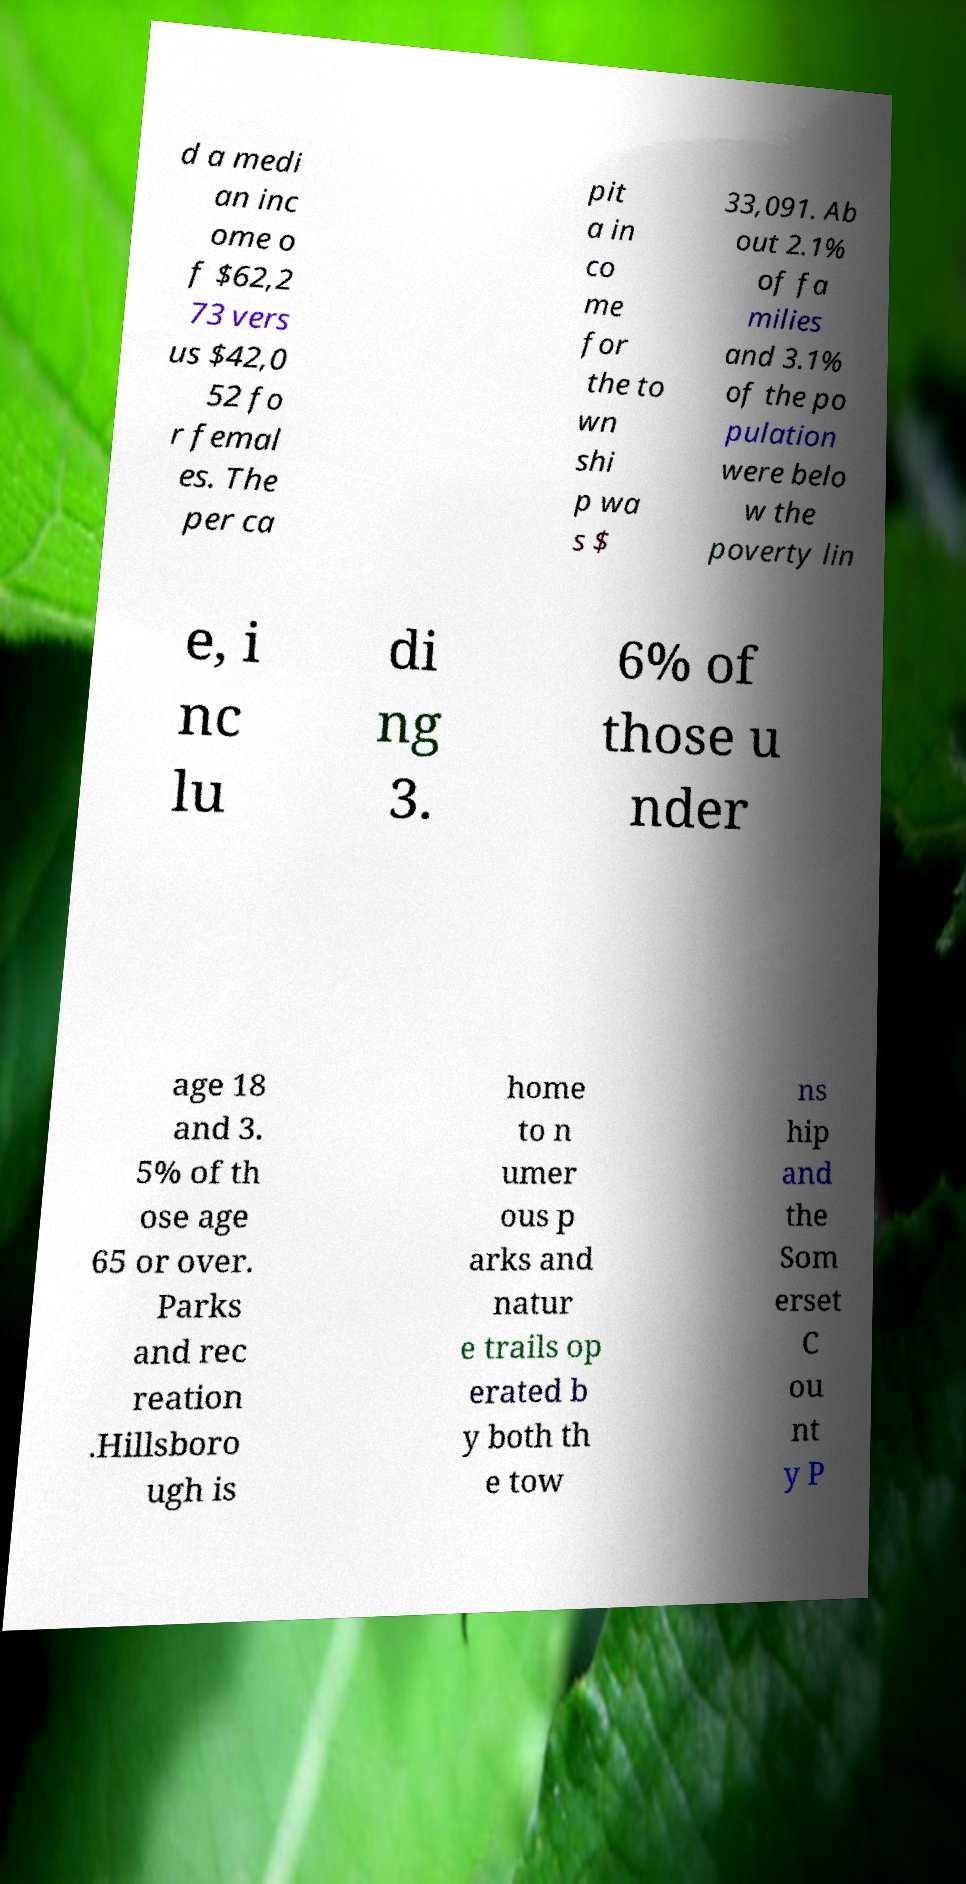Please identify and transcribe the text found in this image. d a medi an inc ome o f $62,2 73 vers us $42,0 52 fo r femal es. The per ca pit a in co me for the to wn shi p wa s $ 33,091. Ab out 2.1% of fa milies and 3.1% of the po pulation were belo w the poverty lin e, i nc lu di ng 3. 6% of those u nder age 18 and 3. 5% of th ose age 65 or over. Parks and rec reation .Hillsboro ugh is home to n umer ous p arks and natur e trails op erated b y both th e tow ns hip and the Som erset C ou nt y P 